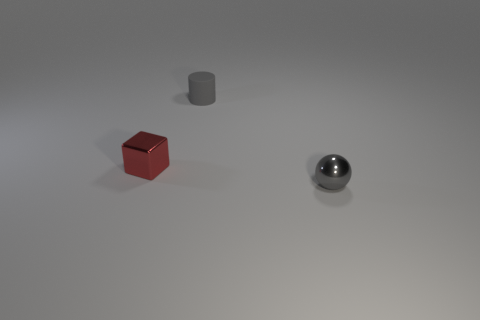Does the tiny red object have the same material as the tiny gray sphere?
Offer a terse response. Yes. What is the color of the rubber cylinder that is the same size as the ball?
Give a very brief answer. Gray. There is a matte object; does it have the same size as the shiny thing that is to the left of the tiny metal sphere?
Your response must be concise. Yes. How many objects are either tiny gray metal objects or yellow blocks?
Offer a very short reply. 1. What number of other things are the same size as the ball?
Offer a very short reply. 2. There is a small cylinder; does it have the same color as the small shiny thing that is on the right side of the gray matte cylinder?
Offer a terse response. Yes. What number of cylinders are either tiny gray objects or large yellow objects?
Offer a terse response. 1. Is there anything else of the same color as the matte thing?
Give a very brief answer. Yes. The tiny gray object that is to the left of the tiny object to the right of the gray rubber cylinder is made of what material?
Offer a very short reply. Rubber. Are the gray sphere and the tiny object that is behind the red block made of the same material?
Your answer should be very brief. No. 